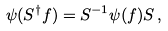<formula> <loc_0><loc_0><loc_500><loc_500>\psi ( S ^ { \dagger } f ) = { S } ^ { - 1 } \psi ( f ) { S } \, ,</formula> 